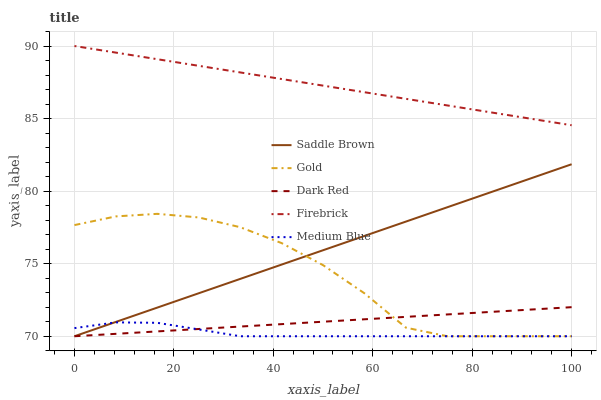Does Firebrick have the minimum area under the curve?
Answer yes or no. No. Does Medium Blue have the maximum area under the curve?
Answer yes or no. No. Is Medium Blue the smoothest?
Answer yes or no. No. Is Medium Blue the roughest?
Answer yes or no. No. Does Firebrick have the lowest value?
Answer yes or no. No. Does Medium Blue have the highest value?
Answer yes or no. No. Is Medium Blue less than Firebrick?
Answer yes or no. Yes. Is Firebrick greater than Gold?
Answer yes or no. Yes. Does Medium Blue intersect Firebrick?
Answer yes or no. No. 